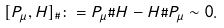Convert formula to latex. <formula><loc_0><loc_0><loc_500><loc_500>[ P _ { \mu } , H ] _ { \# } \colon = P _ { \mu } \# H - H \# P _ { \mu } \sim 0 .</formula> 